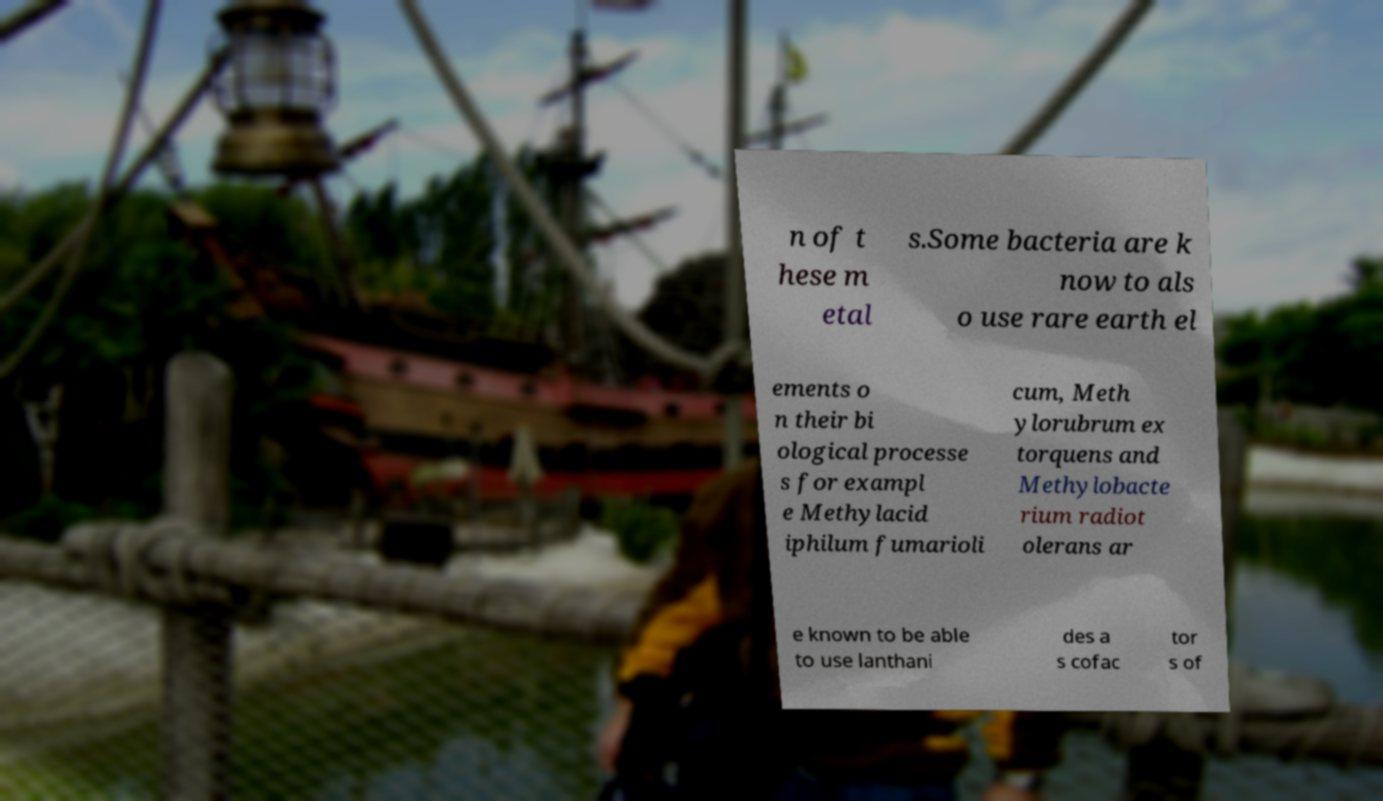Please identify and transcribe the text found in this image. n of t hese m etal s.Some bacteria are k now to als o use rare earth el ements o n their bi ological processe s for exampl e Methylacid iphilum fumarioli cum, Meth ylorubrum ex torquens and Methylobacte rium radiot olerans ar e known to be able to use lanthani des a s cofac tor s of 